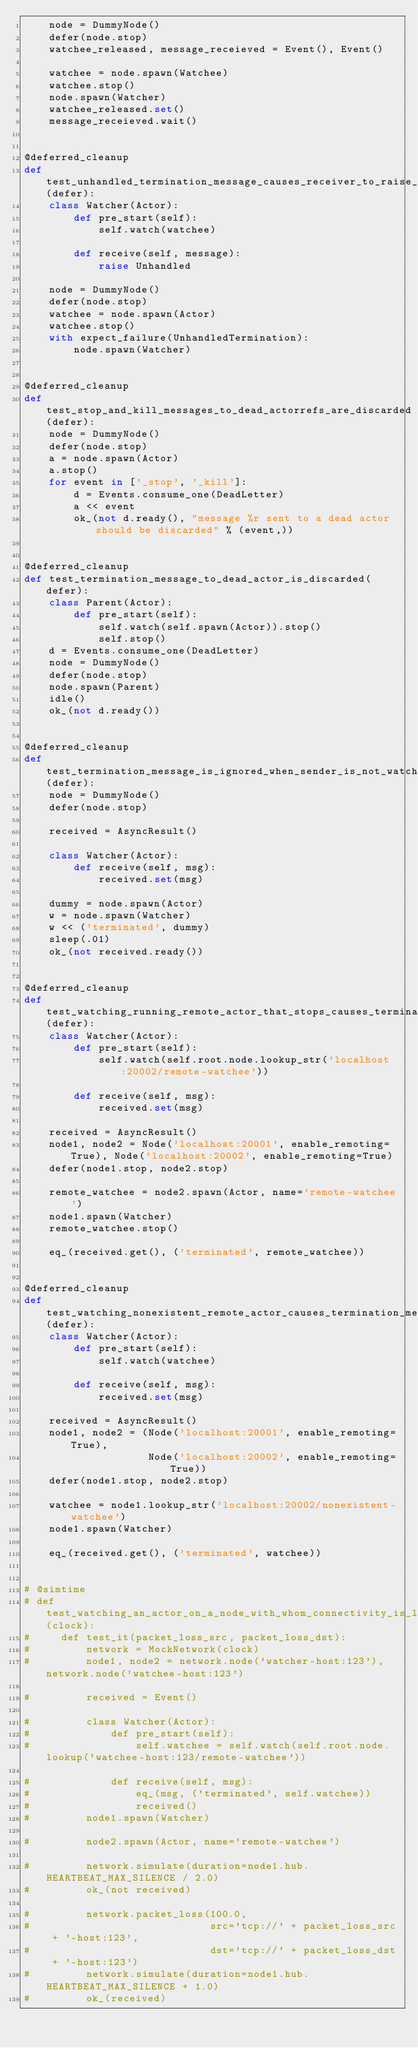Convert code to text. <code><loc_0><loc_0><loc_500><loc_500><_Python_>    node = DummyNode()
    defer(node.stop)
    watchee_released, message_receieved = Event(), Event()

    watchee = node.spawn(Watchee)
    watchee.stop()
    node.spawn(Watcher)
    watchee_released.set()
    message_receieved.wait()


@deferred_cleanup
def test_unhandled_termination_message_causes_receiver_to_raise_unhandledtermination(defer):
    class Watcher(Actor):
        def pre_start(self):
            self.watch(watchee)

        def receive(self, message):
            raise Unhandled

    node = DummyNode()
    defer(node.stop)
    watchee = node.spawn(Actor)
    watchee.stop()
    with expect_failure(UnhandledTermination):
        node.spawn(Watcher)


@deferred_cleanup
def test_stop_and_kill_messages_to_dead_actorrefs_are_discarded(defer):
    node = DummyNode()
    defer(node.stop)
    a = node.spawn(Actor)
    a.stop()
    for event in ['_stop', '_kill']:
        d = Events.consume_one(DeadLetter)
        a << event
        ok_(not d.ready(), "message %r sent to a dead actor should be discarded" % (event,))


@deferred_cleanup
def test_termination_message_to_dead_actor_is_discarded(defer):
    class Parent(Actor):
        def pre_start(self):
            self.watch(self.spawn(Actor)).stop()
            self.stop()
    d = Events.consume_one(DeadLetter)
    node = DummyNode()
    defer(node.stop)
    node.spawn(Parent)
    idle()
    ok_(not d.ready())


@deferred_cleanup
def test_termination_message_is_ignored_when_sender_is_not_watched(defer):
    node = DummyNode()
    defer(node.stop)

    received = AsyncResult()

    class Watcher(Actor):
        def receive(self, msg):
            received.set(msg)

    dummy = node.spawn(Actor)
    w = node.spawn(Watcher)
    w << ('terminated', dummy)
    sleep(.01)
    ok_(not received.ready())


@deferred_cleanup
def test_watching_running_remote_actor_that_stops_causes_termination_message(defer):
    class Watcher(Actor):
        def pre_start(self):
            self.watch(self.root.node.lookup_str('localhost:20002/remote-watchee'))

        def receive(self, msg):
            received.set(msg)

    received = AsyncResult()
    node1, node2 = Node('localhost:20001', enable_remoting=True), Node('localhost:20002', enable_remoting=True)
    defer(node1.stop, node2.stop)

    remote_watchee = node2.spawn(Actor, name='remote-watchee')
    node1.spawn(Watcher)
    remote_watchee.stop()

    eq_(received.get(), ('terminated', remote_watchee))


@deferred_cleanup
def test_watching_nonexistent_remote_actor_causes_termination_message(defer):
    class Watcher(Actor):
        def pre_start(self):
            self.watch(watchee)

        def receive(self, msg):
            received.set(msg)

    received = AsyncResult()
    node1, node2 = (Node('localhost:20001', enable_remoting=True),
                    Node('localhost:20002', enable_remoting=True))
    defer(node1.stop, node2.stop)

    watchee = node1.lookup_str('localhost:20002/nonexistent-watchee')
    node1.spawn(Watcher)

    eq_(received.get(), ('terminated', watchee))


# @simtime
# def test_watching_an_actor_on_a_node_with_whom_connectivity_is_lost_or_limited(clock):
#     def test_it(packet_loss_src, packet_loss_dst):
#         network = MockNetwork(clock)
#         node1, node2 = network.node('watcher-host:123'), network.node('watchee-host:123')

#         received = Event()

#         class Watcher(Actor):
#             def pre_start(self):
#                 self.watchee = self.watch(self.root.node.lookup('watchee-host:123/remote-watchee'))

#             def receive(self, msg):
#                 eq_(msg, ('terminated', self.watchee))
#                 received()
#         node1.spawn(Watcher)

#         node2.spawn(Actor, name='remote-watchee')

#         network.simulate(duration=node1.hub.HEARTBEAT_MAX_SILENCE / 2.0)
#         ok_(not received)

#         network.packet_loss(100.0,
#                             src='tcp://' + packet_loss_src + '-host:123',
#                             dst='tcp://' + packet_loss_dst + '-host:123')
#         network.simulate(duration=node1.hub.HEARTBEAT_MAX_SILENCE + 1.0)
#         ok_(received)
</code> 